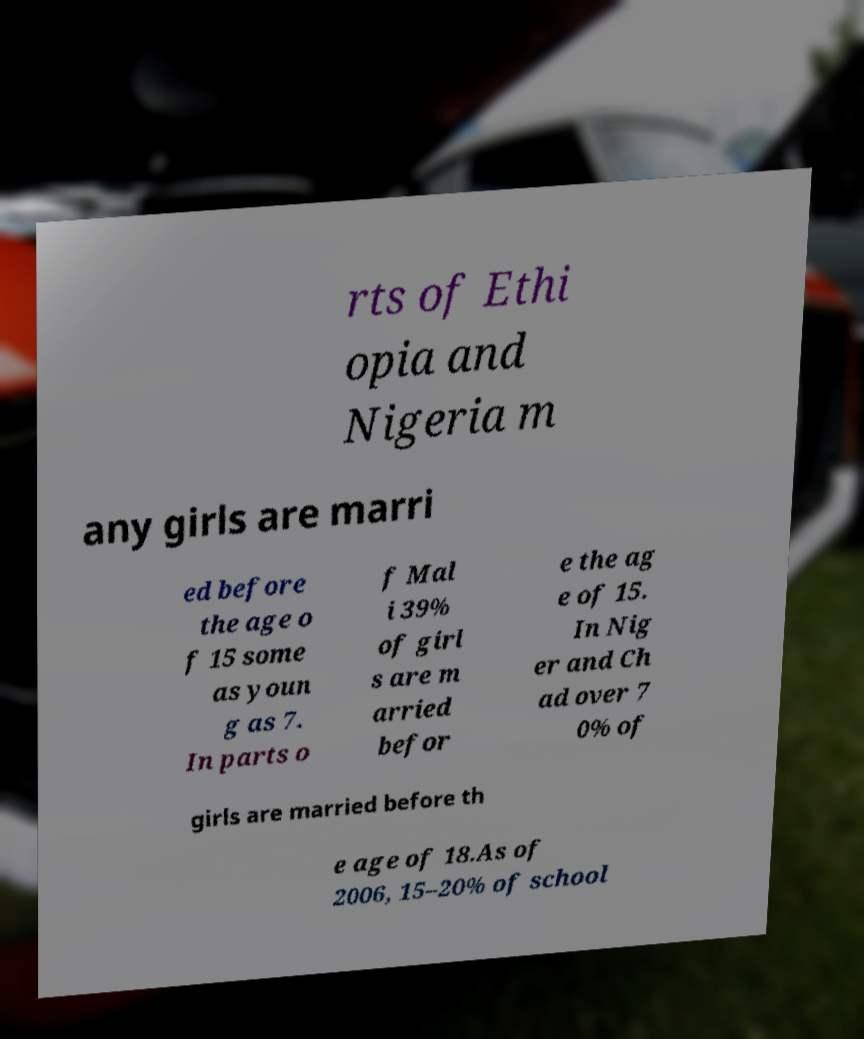I need the written content from this picture converted into text. Can you do that? rts of Ethi opia and Nigeria m any girls are marri ed before the age o f 15 some as youn g as 7. In parts o f Mal i 39% of girl s are m arried befor e the ag e of 15. In Nig er and Ch ad over 7 0% of girls are married before th e age of 18.As of 2006, 15–20% of school 